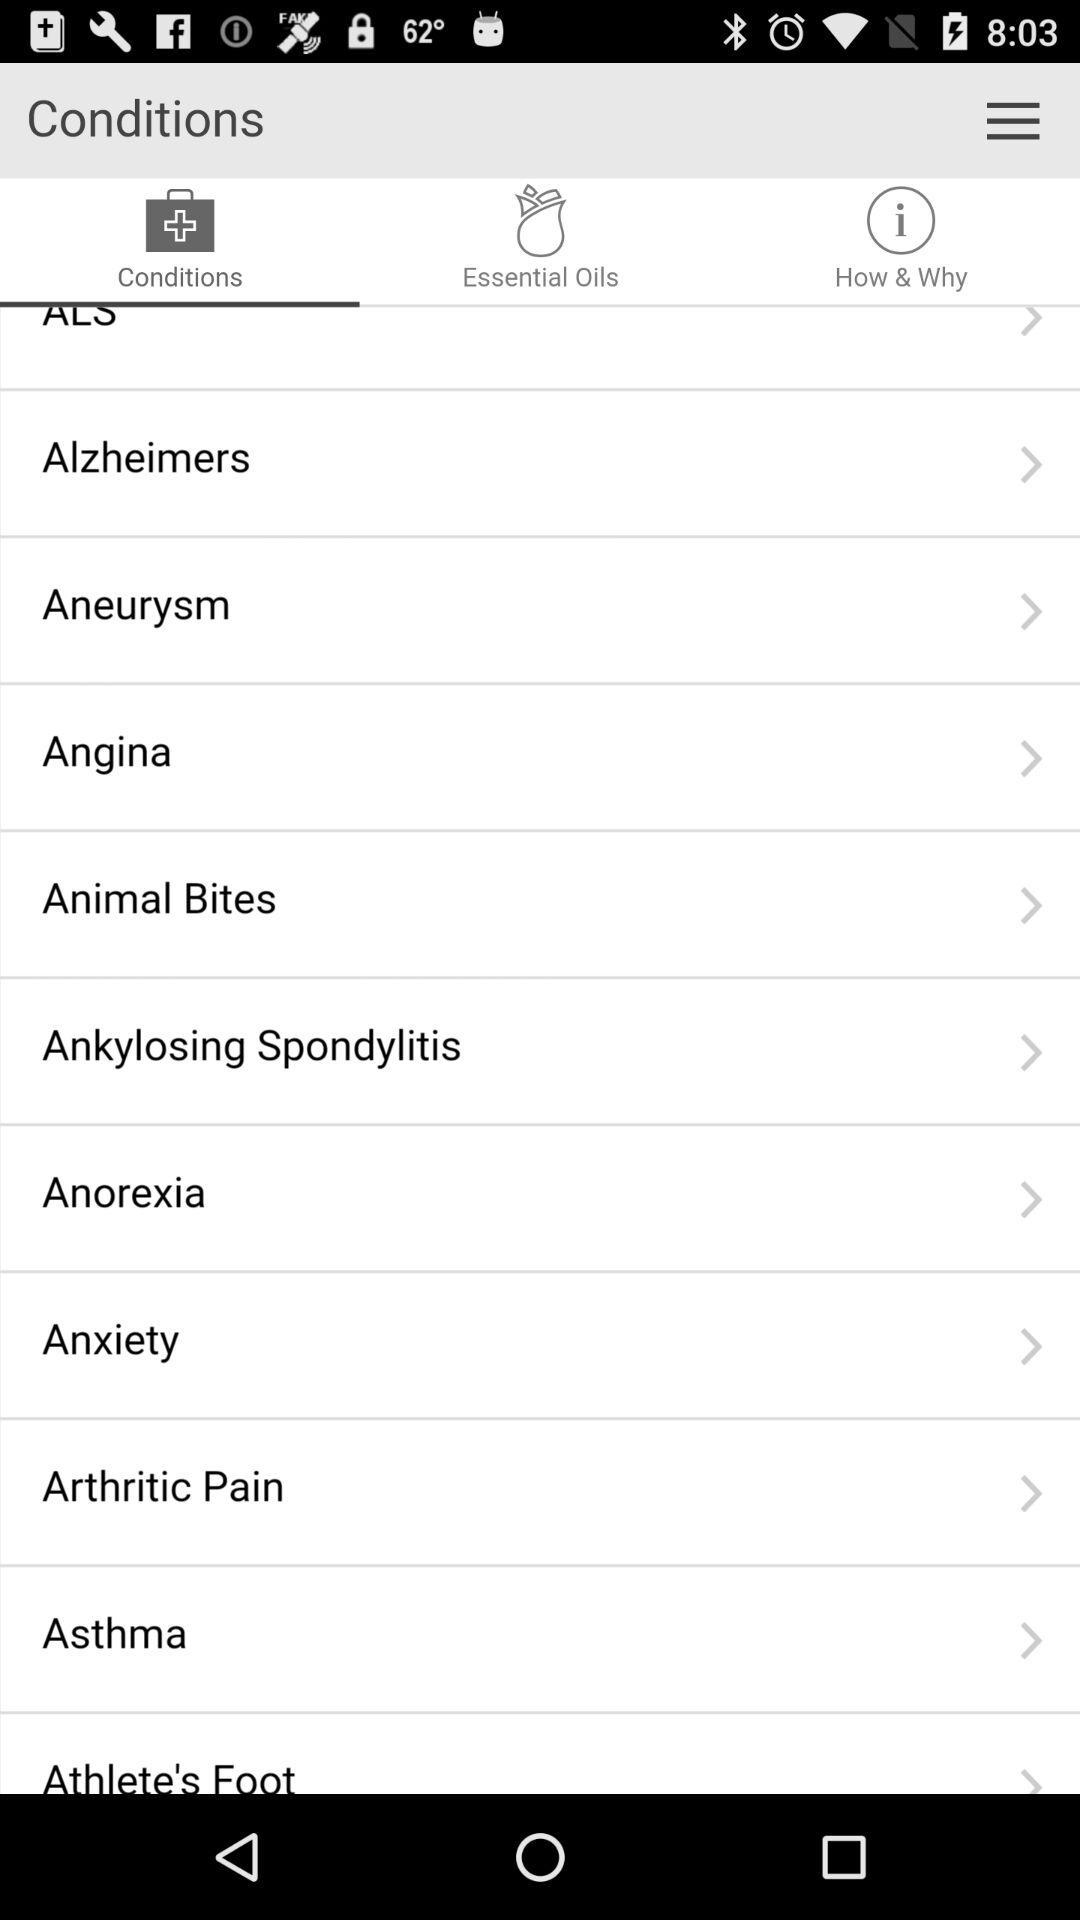Which option is selected? The selected option is "Conditions". 